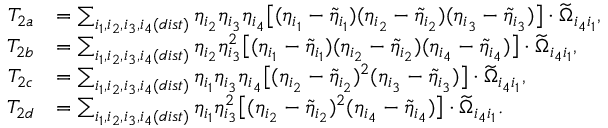Convert formula to latex. <formula><loc_0><loc_0><loc_500><loc_500>\begin{array} { r l } { T _ { 2 a } } & { = \sum _ { i _ { 1 } , i _ { 2 } , i _ { 3 } , i _ { 4 } ( d i s t ) } \eta _ { i _ { 2 } } \eta _ { i _ { 3 } } \eta _ { i _ { 4 } } \left [ ( \eta _ { i _ { 1 } } - \tilde { \eta } _ { i _ { 1 } } ) ( \eta _ { i _ { 2 } } - \tilde { \eta } _ { i _ { 2 } } ) ( \eta _ { i _ { 3 } } - \tilde { \eta } _ { i _ { 3 } } ) \right ] \cdot \widetilde { \Omega } _ { i _ { 4 } i _ { 1 } } , } \\ { T _ { 2 b } } & { = \sum _ { i _ { 1 } , i _ { 2 } , i _ { 3 } , i _ { 4 } ( d i s t ) } \eta _ { i _ { 2 } } \eta _ { i _ { 3 } } ^ { 2 } \left [ ( \eta _ { i _ { 1 } } - \tilde { \eta } _ { i _ { 1 } } ) ( \eta _ { i _ { 2 } } - \tilde { \eta } _ { i _ { 2 } } ) ( \eta _ { i _ { 4 } } - \tilde { \eta } _ { i _ { 4 } } ) \right ] \cdot \widetilde { \Omega } _ { i _ { 4 } i _ { 1 } } , } \\ { T _ { 2 c } } & { = \sum _ { i _ { 1 } , i _ { 2 } , i _ { 3 } , i _ { 4 } ( d i s t ) } \eta _ { i _ { 1 } } \eta _ { i _ { 3 } } \eta _ { i _ { 4 } } \left [ ( \eta _ { i _ { 2 } } - \tilde { \eta } _ { i _ { 2 } } ) ^ { 2 } ( \eta _ { i _ { 3 } } - \tilde { \eta } _ { i _ { 3 } } ) \right ] \cdot \widetilde { \Omega } _ { i _ { 4 } i _ { 1 } } , } \\ { T _ { 2 d } } & { = \sum _ { i _ { 1 } , i _ { 2 } , i _ { 3 } , i _ { 4 } ( d i s t ) } \eta _ { i _ { 1 } } \eta _ { i _ { 3 } } ^ { 2 } \left [ ( \eta _ { i _ { 2 } } - \tilde { \eta } _ { i _ { 2 } } ) ^ { 2 } ( \eta _ { i _ { 4 } } - \tilde { \eta } _ { i _ { 4 } } ) \right ] \cdot \widetilde { \Omega } _ { i _ { 4 } i _ { 1 } } . } \end{array}</formula> 